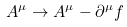<formula> <loc_0><loc_0><loc_500><loc_500>A ^ { \mu } \rightarrow A ^ { \mu } - \partial ^ { \mu } f</formula> 